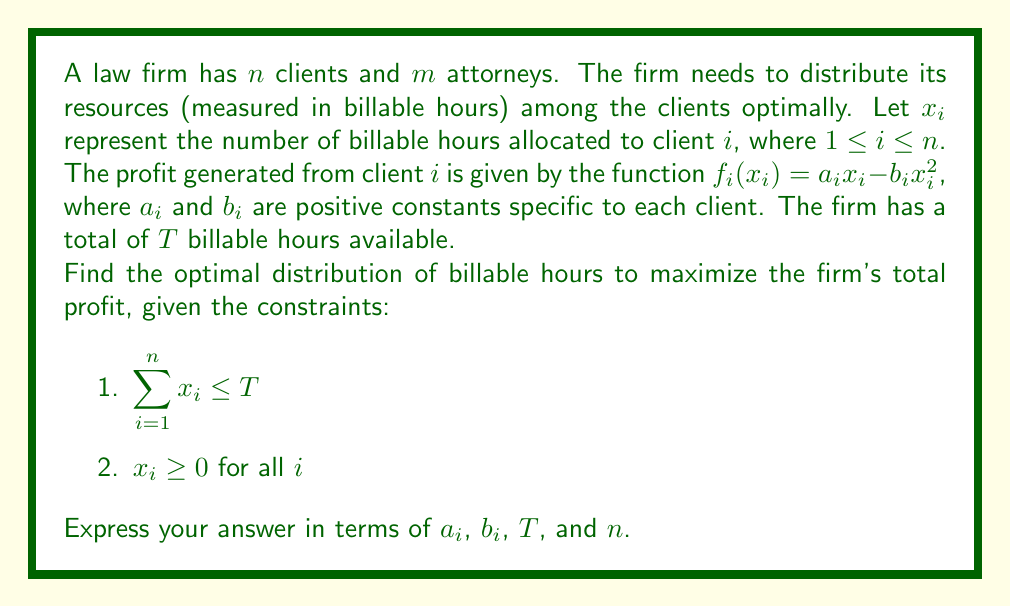Teach me how to tackle this problem. To solve this optimization problem, we'll use the method of Lagrange multipliers:

1) First, we form the Lagrangian function:

   $$L(x_1, \ldots, x_n, \lambda) = \sum_{i=1}^n (a_ix_i - b_ix_i^2) - \lambda(\sum_{i=1}^n x_i - T)$$

2) Now, we take partial derivatives with respect to each $x_i$ and $\lambda$:

   $$\frac{\partial L}{\partial x_i} = a_i - 2b_ix_i - \lambda = 0$$
   $$\frac{\partial L}{\partial \lambda} = T - \sum_{i=1}^n x_i = 0$$

3) From the first equation, we can express $x_i$ in terms of $\lambda$:

   $$x_i = \frac{a_i - \lambda}{2b_i}$$

4) Substituting this into the second equation:

   $$T = \sum_{i=1}^n \frac{a_i - \lambda}{2b_i}$$

5) Solving for $\lambda$:

   $$\lambda = \frac{\sum_{i=1}^n \frac{a_i}{2b_i} - T}{\sum_{i=1}^n \frac{1}{2b_i}}$$

6) Substituting this back into the expression for $x_i$:

   $$x_i = \frac{a_i}{2b_i} - \frac{1}{2b_i} \cdot \frac{\sum_{j=1}^n \frac{a_j}{2b_j} - T}{\sum_{j=1}^n \frac{1}{2b_j}}$$

This gives us the optimal distribution of billable hours for each client.
Answer: The optimal distribution of billable hours for client $i$ is:

$$x_i = \frac{a_i}{2b_i} - \frac{1}{2b_i} \cdot \frac{\sum_{j=1}^n \frac{a_j}{2b_j} - T}{\sum_{j=1}^n \frac{1}{2b_j}}$$

where $1 \leq i \leq n$, and $a_i$, $b_i$, $T$, and $n$ are as defined in the problem statement. 